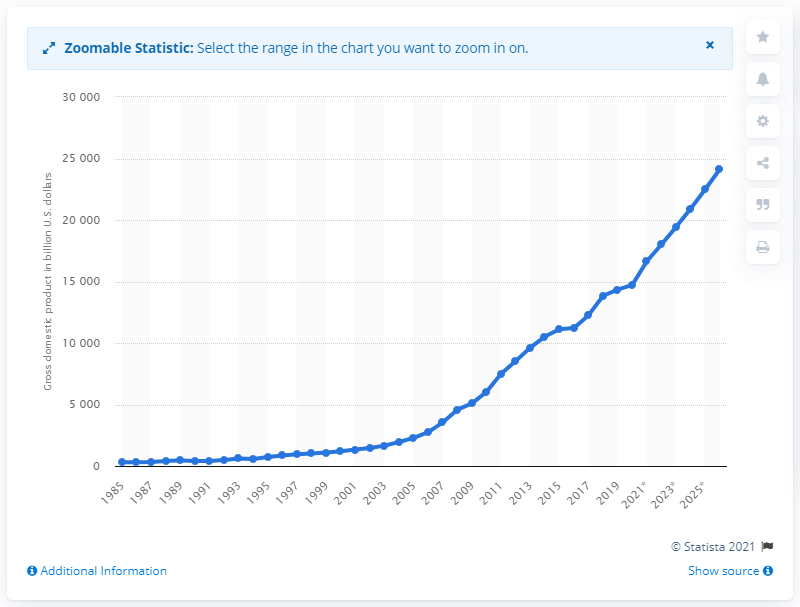Give some essential details in this illustration. In 2020, the Gross Domestic Product (GDP) of China was valued at 147,228.84 U.S. dollars. 